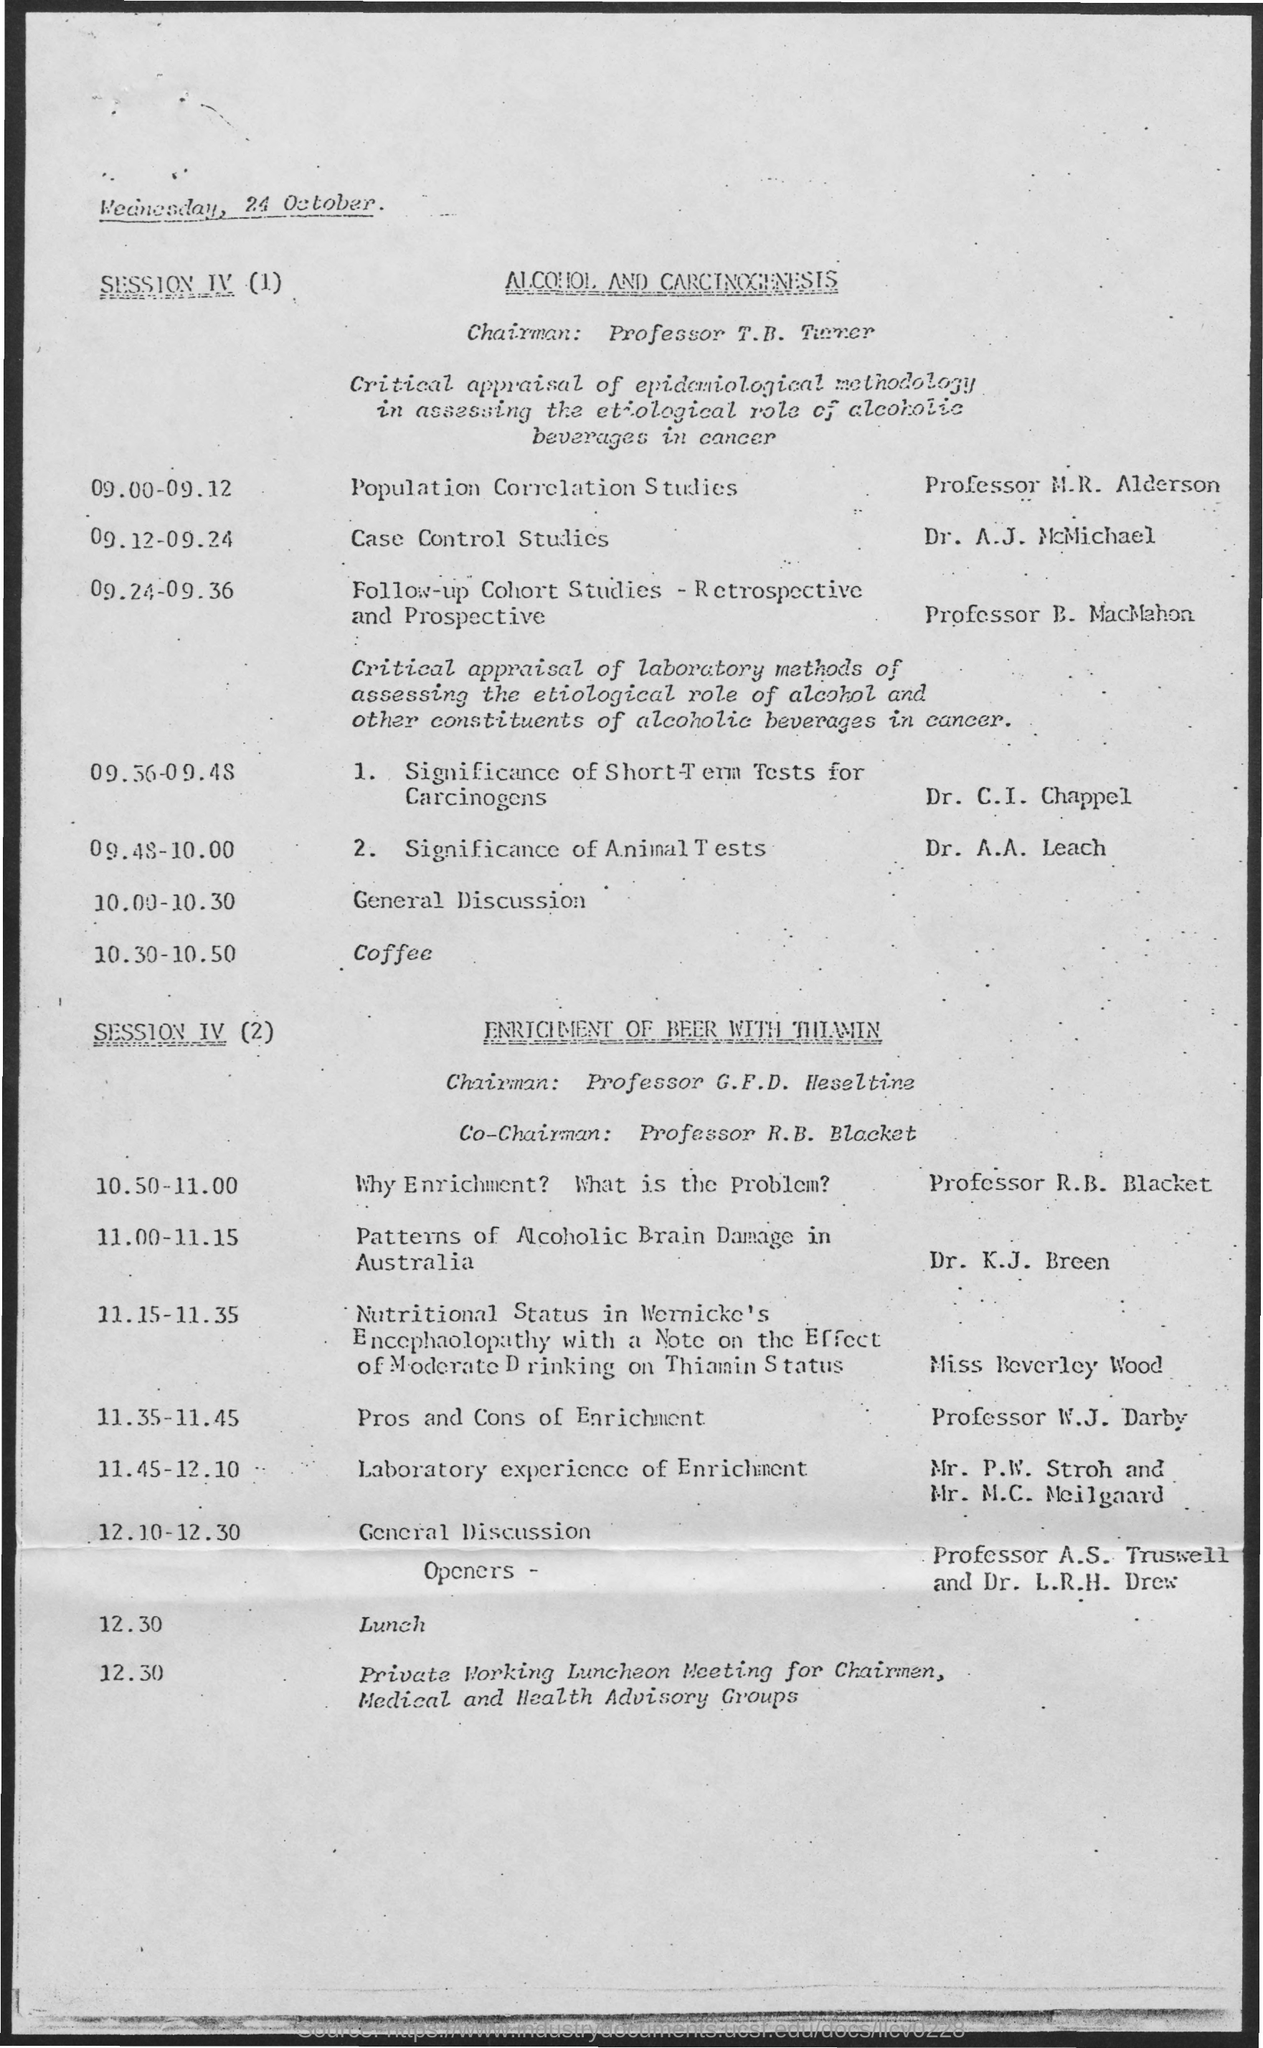Give some essential details in this illustration. The fourth session of the meeting is discussing the topic of alcohol and carcinogenesis. Professor G.F.D. Heseltine is the chairman for SESSION IV (2). The document is dated Wednesday, 24 October... From 09.00-09.12, the event was Population Correlation Studies. The event "Patterns of Alcoholic Brain Damage in Australia" is scheduled to take place from 11:00-11:15 AM. 